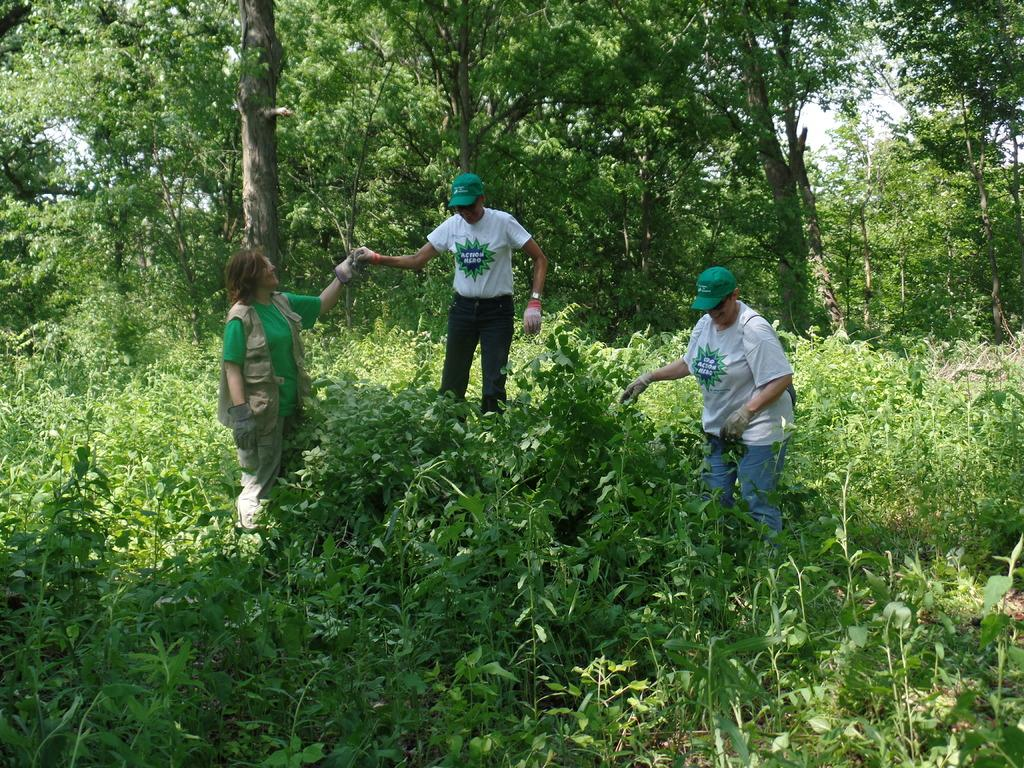How many people are in the image? There are three persons in the image. What are the persons wearing on their hands? The persons are wearing gloves. What type of vegetation can be seen in the image? There are plants and trees in the image. What is visible in the sky in the image? The sky is visible in the image. What type of chalk is being used to draw on the alley in the image? There is no chalk or alley present in the image. How are the persons maintaining their balance while wearing the gloves in the image? The image does not provide information about the persons' balance or any activities they might be doing while wearing gloves. 